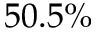Convert formula to latex. <formula><loc_0><loc_0><loc_500><loc_500>5 0 . 5 \%</formula> 